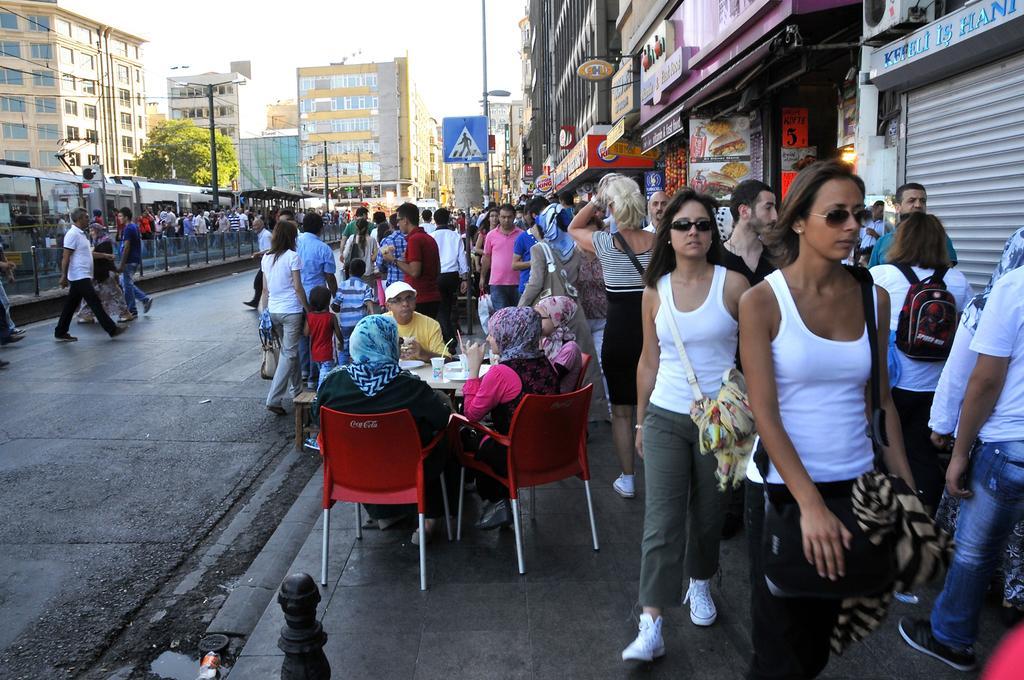Please provide a concise description of this image. In the image we can see there are people standing on the footpath and there are other people sitting on the chairs. There are few people crossing the road and there is a train. Behind there is a tree and there are lot of buildings. There are street light poles and the sky is clear. 